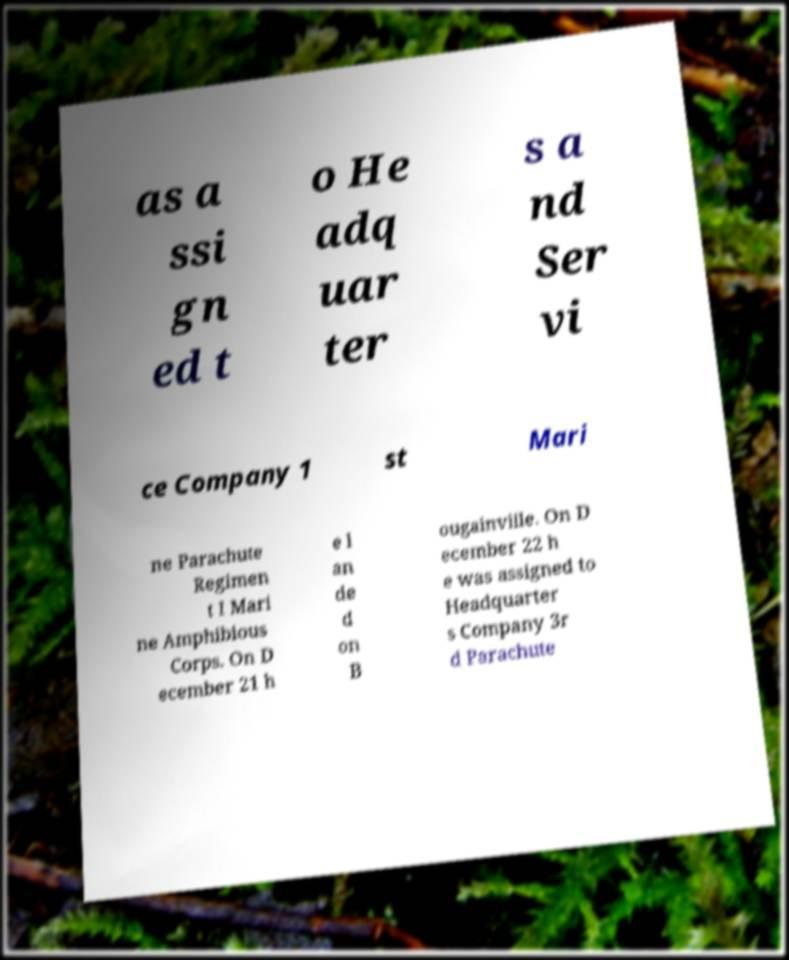Please read and relay the text visible in this image. What does it say? as a ssi gn ed t o He adq uar ter s a nd Ser vi ce Company 1 st Mari ne Parachute Regimen t I Mari ne Amphibious Corps. On D ecember 21 h e l an de d on B ougainville. On D ecember 22 h e was assigned to Headquarter s Company 3r d Parachute 